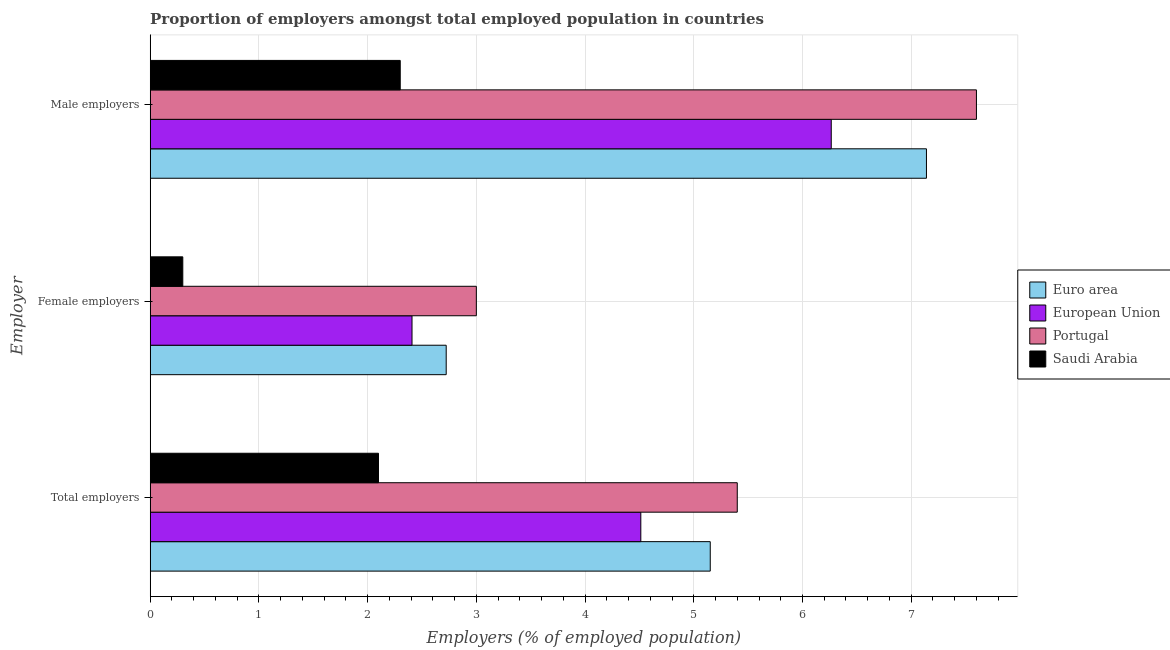How many different coloured bars are there?
Give a very brief answer. 4. Are the number of bars per tick equal to the number of legend labels?
Give a very brief answer. Yes. Are the number of bars on each tick of the Y-axis equal?
Offer a very short reply. Yes. How many bars are there on the 3rd tick from the top?
Offer a very short reply. 4. How many bars are there on the 3rd tick from the bottom?
Your answer should be compact. 4. What is the label of the 1st group of bars from the top?
Keep it short and to the point. Male employers. What is the percentage of female employers in Saudi Arabia?
Give a very brief answer. 0.3. Across all countries, what is the minimum percentage of total employers?
Provide a short and direct response. 2.1. In which country was the percentage of female employers maximum?
Your answer should be compact. Portugal. In which country was the percentage of total employers minimum?
Your answer should be very brief. Saudi Arabia. What is the total percentage of total employers in the graph?
Offer a terse response. 17.16. What is the difference between the percentage of female employers in Euro area and that in Portugal?
Your response must be concise. -0.28. What is the difference between the percentage of female employers in Saudi Arabia and the percentage of total employers in European Union?
Your answer should be compact. -4.21. What is the average percentage of total employers per country?
Make the answer very short. 4.29. What is the difference between the percentage of male employers and percentage of total employers in Portugal?
Your answer should be compact. 2.2. In how many countries, is the percentage of female employers greater than 5.4 %?
Your answer should be very brief. 0. What is the ratio of the percentage of male employers in European Union to that in Portugal?
Give a very brief answer. 0.82. Is the percentage of female employers in Saudi Arabia less than that in Portugal?
Your response must be concise. Yes. Is the difference between the percentage of female employers in Portugal and Saudi Arabia greater than the difference between the percentage of total employers in Portugal and Saudi Arabia?
Offer a very short reply. No. What is the difference between the highest and the second highest percentage of total employers?
Offer a terse response. 0.25. What is the difference between the highest and the lowest percentage of female employers?
Offer a very short reply. 2.7. In how many countries, is the percentage of total employers greater than the average percentage of total employers taken over all countries?
Provide a succinct answer. 3. What does the 2nd bar from the top in Male employers represents?
Your answer should be compact. Portugal. What does the 3rd bar from the bottom in Total employers represents?
Offer a very short reply. Portugal. How many countries are there in the graph?
Offer a terse response. 4. What is the difference between two consecutive major ticks on the X-axis?
Offer a terse response. 1. Are the values on the major ticks of X-axis written in scientific E-notation?
Make the answer very short. No. Does the graph contain grids?
Your answer should be very brief. Yes. Where does the legend appear in the graph?
Ensure brevity in your answer.  Center right. How are the legend labels stacked?
Offer a very short reply. Vertical. What is the title of the graph?
Make the answer very short. Proportion of employers amongst total employed population in countries. Does "Sub-Saharan Africa (all income levels)" appear as one of the legend labels in the graph?
Provide a short and direct response. No. What is the label or title of the X-axis?
Give a very brief answer. Employers (% of employed population). What is the label or title of the Y-axis?
Keep it short and to the point. Employer. What is the Employers (% of employed population) in Euro area in Total employers?
Ensure brevity in your answer.  5.15. What is the Employers (% of employed population) of European Union in Total employers?
Your answer should be compact. 4.51. What is the Employers (% of employed population) of Portugal in Total employers?
Provide a succinct answer. 5.4. What is the Employers (% of employed population) in Saudi Arabia in Total employers?
Offer a terse response. 2.1. What is the Employers (% of employed population) in Euro area in Female employers?
Ensure brevity in your answer.  2.72. What is the Employers (% of employed population) of European Union in Female employers?
Your answer should be very brief. 2.41. What is the Employers (% of employed population) in Portugal in Female employers?
Give a very brief answer. 3. What is the Employers (% of employed population) in Saudi Arabia in Female employers?
Provide a succinct answer. 0.3. What is the Employers (% of employed population) of Euro area in Male employers?
Ensure brevity in your answer.  7.14. What is the Employers (% of employed population) of European Union in Male employers?
Provide a short and direct response. 6.26. What is the Employers (% of employed population) of Portugal in Male employers?
Keep it short and to the point. 7.6. What is the Employers (% of employed population) in Saudi Arabia in Male employers?
Ensure brevity in your answer.  2.3. Across all Employer, what is the maximum Employers (% of employed population) of Euro area?
Provide a succinct answer. 7.14. Across all Employer, what is the maximum Employers (% of employed population) in European Union?
Make the answer very short. 6.26. Across all Employer, what is the maximum Employers (% of employed population) in Portugal?
Keep it short and to the point. 7.6. Across all Employer, what is the maximum Employers (% of employed population) of Saudi Arabia?
Your answer should be compact. 2.3. Across all Employer, what is the minimum Employers (% of employed population) in Euro area?
Offer a very short reply. 2.72. Across all Employer, what is the minimum Employers (% of employed population) of European Union?
Offer a very short reply. 2.41. Across all Employer, what is the minimum Employers (% of employed population) of Portugal?
Your response must be concise. 3. Across all Employer, what is the minimum Employers (% of employed population) in Saudi Arabia?
Provide a succinct answer. 0.3. What is the total Employers (% of employed population) in Euro area in the graph?
Offer a terse response. 15.01. What is the total Employers (% of employed population) in European Union in the graph?
Provide a short and direct response. 13.19. What is the total Employers (% of employed population) in Portugal in the graph?
Provide a succinct answer. 16. What is the difference between the Employers (% of employed population) in Euro area in Total employers and that in Female employers?
Offer a very short reply. 2.43. What is the difference between the Employers (% of employed population) in European Union in Total employers and that in Female employers?
Make the answer very short. 2.1. What is the difference between the Employers (% of employed population) of Euro area in Total employers and that in Male employers?
Ensure brevity in your answer.  -1.99. What is the difference between the Employers (% of employed population) in European Union in Total employers and that in Male employers?
Provide a succinct answer. -1.75. What is the difference between the Employers (% of employed population) of Portugal in Total employers and that in Male employers?
Offer a terse response. -2.2. What is the difference between the Employers (% of employed population) in Saudi Arabia in Total employers and that in Male employers?
Offer a terse response. -0.2. What is the difference between the Employers (% of employed population) of Euro area in Female employers and that in Male employers?
Keep it short and to the point. -4.42. What is the difference between the Employers (% of employed population) in European Union in Female employers and that in Male employers?
Provide a succinct answer. -3.86. What is the difference between the Employers (% of employed population) in Saudi Arabia in Female employers and that in Male employers?
Your response must be concise. -2. What is the difference between the Employers (% of employed population) of Euro area in Total employers and the Employers (% of employed population) of European Union in Female employers?
Make the answer very short. 2.74. What is the difference between the Employers (% of employed population) of Euro area in Total employers and the Employers (% of employed population) of Portugal in Female employers?
Your response must be concise. 2.15. What is the difference between the Employers (% of employed population) of Euro area in Total employers and the Employers (% of employed population) of Saudi Arabia in Female employers?
Your response must be concise. 4.85. What is the difference between the Employers (% of employed population) of European Union in Total employers and the Employers (% of employed population) of Portugal in Female employers?
Give a very brief answer. 1.51. What is the difference between the Employers (% of employed population) of European Union in Total employers and the Employers (% of employed population) of Saudi Arabia in Female employers?
Provide a short and direct response. 4.21. What is the difference between the Employers (% of employed population) in Portugal in Total employers and the Employers (% of employed population) in Saudi Arabia in Female employers?
Your response must be concise. 5.1. What is the difference between the Employers (% of employed population) in Euro area in Total employers and the Employers (% of employed population) in European Union in Male employers?
Offer a very short reply. -1.11. What is the difference between the Employers (% of employed population) in Euro area in Total employers and the Employers (% of employed population) in Portugal in Male employers?
Offer a terse response. -2.45. What is the difference between the Employers (% of employed population) in Euro area in Total employers and the Employers (% of employed population) in Saudi Arabia in Male employers?
Offer a very short reply. 2.85. What is the difference between the Employers (% of employed population) of European Union in Total employers and the Employers (% of employed population) of Portugal in Male employers?
Keep it short and to the point. -3.09. What is the difference between the Employers (% of employed population) in European Union in Total employers and the Employers (% of employed population) in Saudi Arabia in Male employers?
Offer a terse response. 2.21. What is the difference between the Employers (% of employed population) of Euro area in Female employers and the Employers (% of employed population) of European Union in Male employers?
Provide a short and direct response. -3.54. What is the difference between the Employers (% of employed population) of Euro area in Female employers and the Employers (% of employed population) of Portugal in Male employers?
Provide a succinct answer. -4.88. What is the difference between the Employers (% of employed population) in Euro area in Female employers and the Employers (% of employed population) in Saudi Arabia in Male employers?
Offer a terse response. 0.42. What is the difference between the Employers (% of employed population) of European Union in Female employers and the Employers (% of employed population) of Portugal in Male employers?
Offer a very short reply. -5.19. What is the difference between the Employers (% of employed population) of European Union in Female employers and the Employers (% of employed population) of Saudi Arabia in Male employers?
Provide a succinct answer. 0.11. What is the average Employers (% of employed population) of Euro area per Employer?
Make the answer very short. 5. What is the average Employers (% of employed population) of European Union per Employer?
Your answer should be very brief. 4.4. What is the average Employers (% of employed population) in Portugal per Employer?
Keep it short and to the point. 5.33. What is the average Employers (% of employed population) in Saudi Arabia per Employer?
Offer a very short reply. 1.57. What is the difference between the Employers (% of employed population) of Euro area and Employers (% of employed population) of European Union in Total employers?
Your answer should be very brief. 0.64. What is the difference between the Employers (% of employed population) in Euro area and Employers (% of employed population) in Portugal in Total employers?
Your answer should be very brief. -0.25. What is the difference between the Employers (% of employed population) in Euro area and Employers (% of employed population) in Saudi Arabia in Total employers?
Keep it short and to the point. 3.05. What is the difference between the Employers (% of employed population) in European Union and Employers (% of employed population) in Portugal in Total employers?
Keep it short and to the point. -0.89. What is the difference between the Employers (% of employed population) in European Union and Employers (% of employed population) in Saudi Arabia in Total employers?
Keep it short and to the point. 2.41. What is the difference between the Employers (% of employed population) in Portugal and Employers (% of employed population) in Saudi Arabia in Total employers?
Provide a short and direct response. 3.3. What is the difference between the Employers (% of employed population) in Euro area and Employers (% of employed population) in European Union in Female employers?
Provide a succinct answer. 0.31. What is the difference between the Employers (% of employed population) of Euro area and Employers (% of employed population) of Portugal in Female employers?
Offer a terse response. -0.28. What is the difference between the Employers (% of employed population) of Euro area and Employers (% of employed population) of Saudi Arabia in Female employers?
Offer a terse response. 2.42. What is the difference between the Employers (% of employed population) in European Union and Employers (% of employed population) in Portugal in Female employers?
Give a very brief answer. -0.59. What is the difference between the Employers (% of employed population) in European Union and Employers (% of employed population) in Saudi Arabia in Female employers?
Make the answer very short. 2.11. What is the difference between the Employers (% of employed population) of Euro area and Employers (% of employed population) of European Union in Male employers?
Ensure brevity in your answer.  0.88. What is the difference between the Employers (% of employed population) of Euro area and Employers (% of employed population) of Portugal in Male employers?
Offer a terse response. -0.46. What is the difference between the Employers (% of employed population) in Euro area and Employers (% of employed population) in Saudi Arabia in Male employers?
Provide a short and direct response. 4.84. What is the difference between the Employers (% of employed population) in European Union and Employers (% of employed population) in Portugal in Male employers?
Offer a very short reply. -1.34. What is the difference between the Employers (% of employed population) of European Union and Employers (% of employed population) of Saudi Arabia in Male employers?
Provide a short and direct response. 3.96. What is the difference between the Employers (% of employed population) in Portugal and Employers (% of employed population) in Saudi Arabia in Male employers?
Give a very brief answer. 5.3. What is the ratio of the Employers (% of employed population) in Euro area in Total employers to that in Female employers?
Give a very brief answer. 1.89. What is the ratio of the Employers (% of employed population) of European Union in Total employers to that in Female employers?
Make the answer very short. 1.87. What is the ratio of the Employers (% of employed population) of Euro area in Total employers to that in Male employers?
Ensure brevity in your answer.  0.72. What is the ratio of the Employers (% of employed population) of European Union in Total employers to that in Male employers?
Ensure brevity in your answer.  0.72. What is the ratio of the Employers (% of employed population) of Portugal in Total employers to that in Male employers?
Offer a terse response. 0.71. What is the ratio of the Employers (% of employed population) in Euro area in Female employers to that in Male employers?
Keep it short and to the point. 0.38. What is the ratio of the Employers (% of employed population) of European Union in Female employers to that in Male employers?
Provide a short and direct response. 0.38. What is the ratio of the Employers (% of employed population) in Portugal in Female employers to that in Male employers?
Provide a succinct answer. 0.39. What is the ratio of the Employers (% of employed population) of Saudi Arabia in Female employers to that in Male employers?
Provide a succinct answer. 0.13. What is the difference between the highest and the second highest Employers (% of employed population) in Euro area?
Your answer should be very brief. 1.99. What is the difference between the highest and the second highest Employers (% of employed population) in European Union?
Your answer should be compact. 1.75. What is the difference between the highest and the second highest Employers (% of employed population) of Portugal?
Your response must be concise. 2.2. What is the difference between the highest and the lowest Employers (% of employed population) in Euro area?
Your answer should be compact. 4.42. What is the difference between the highest and the lowest Employers (% of employed population) in European Union?
Provide a succinct answer. 3.86. What is the difference between the highest and the lowest Employers (% of employed population) in Saudi Arabia?
Give a very brief answer. 2. 